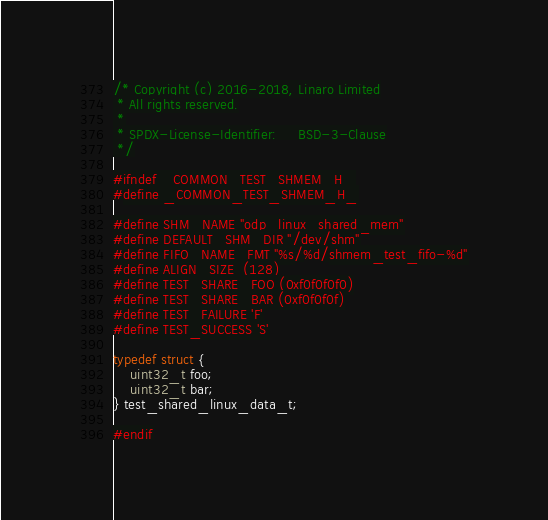Convert code to text. <code><loc_0><loc_0><loc_500><loc_500><_C_>/* Copyright (c) 2016-2018, Linaro Limited
 * All rights reserved.
 *
 * SPDX-License-Identifier:     BSD-3-Clause
 */

#ifndef _COMMON_TEST_SHMEM_H_
#define _COMMON_TEST_SHMEM_H_

#define SHM_NAME "odp_linux_shared_mem"
#define DEFAULT_SHM_DIR "/dev/shm"
#define FIFO_NAME_FMT "%s/%d/shmem_test_fifo-%d"
#define ALIGN_SIZE  (128)
#define TEST_SHARE_FOO (0xf0f0f0f0)
#define TEST_SHARE_BAR (0xf0f0f0f)
#define TEST_FAILURE 'F'
#define TEST_SUCCESS 'S'

typedef struct {
	uint32_t foo;
	uint32_t bar;
} test_shared_linux_data_t;

#endif
</code> 